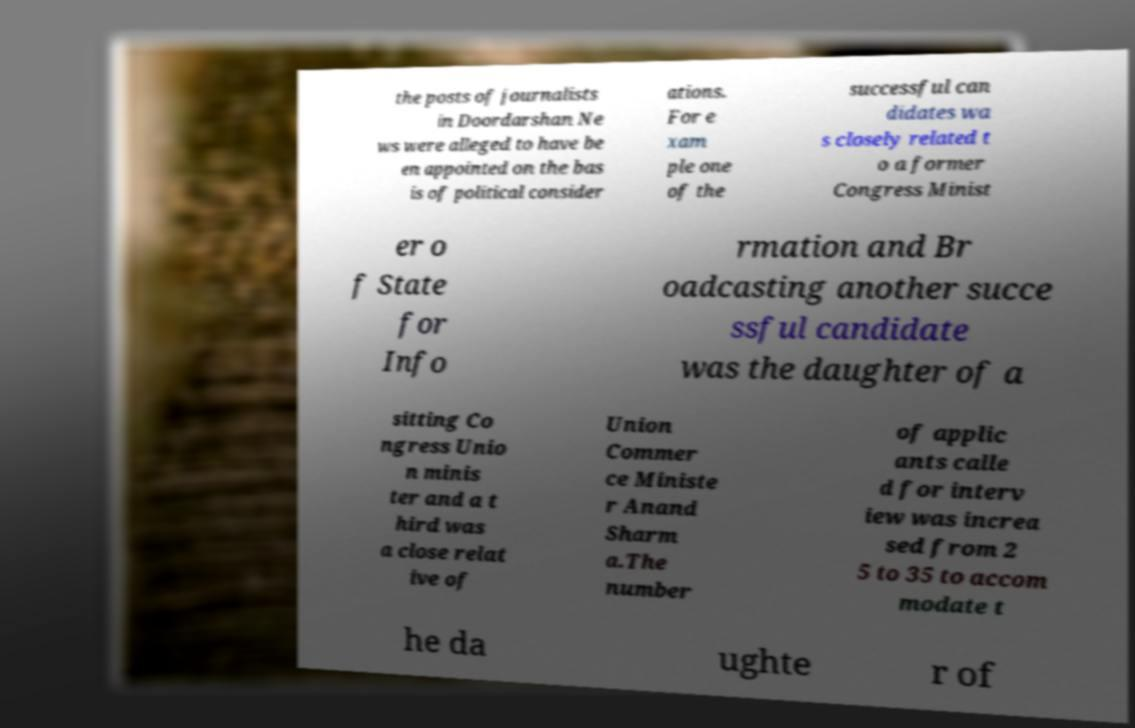There's text embedded in this image that I need extracted. Can you transcribe it verbatim? the posts of journalists in Doordarshan Ne ws were alleged to have be en appointed on the bas is of political consider ations. For e xam ple one of the successful can didates wa s closely related t o a former Congress Minist er o f State for Info rmation and Br oadcasting another succe ssful candidate was the daughter of a sitting Co ngress Unio n minis ter and a t hird was a close relat ive of Union Commer ce Ministe r Anand Sharm a.The number of applic ants calle d for interv iew was increa sed from 2 5 to 35 to accom modate t he da ughte r of 